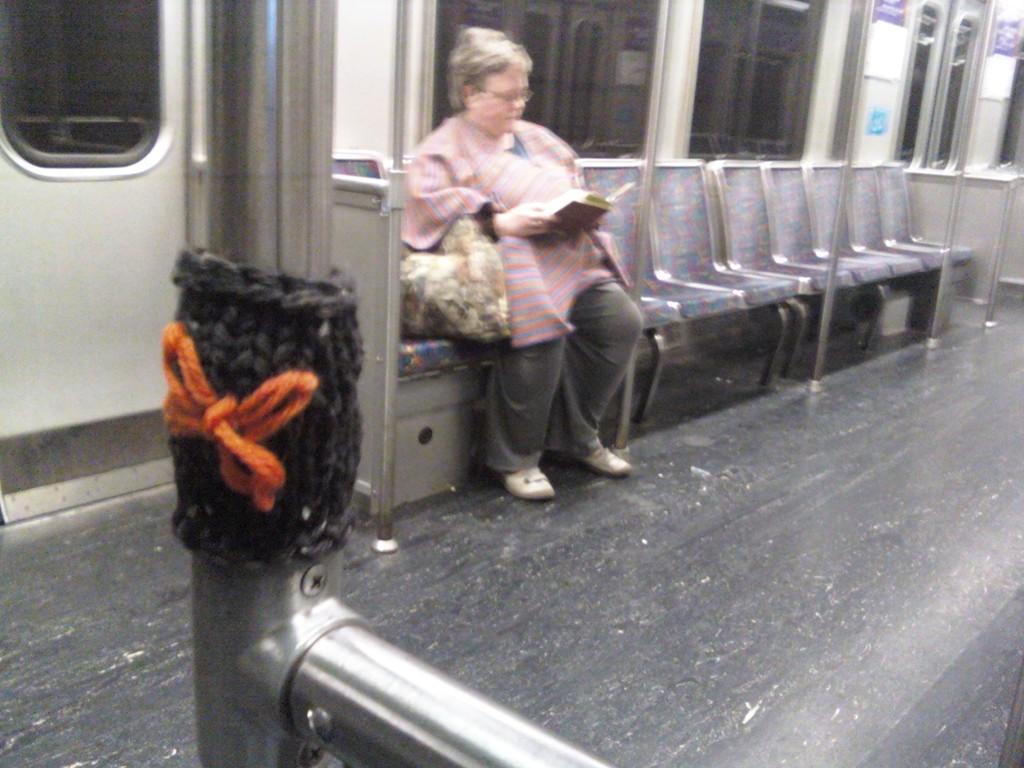In one or two sentences, can you explain what this image depicts? In this picture there is interior of a train and and there is a woman sitting in a chair and holding a book in her hand and there are few empty chairs and poles beside her. 